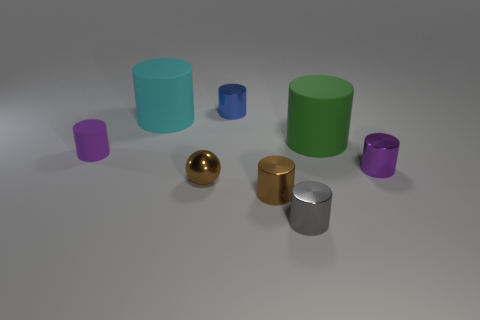Is there any other thing that is the same shape as the purple rubber thing?
Make the answer very short. Yes. Does the purple matte object have the same shape as the large green matte thing?
Keep it short and to the point. Yes. Is the number of metallic balls right of the large green rubber cylinder the same as the number of cyan rubber cylinders that are on the right side of the tiny brown shiny cylinder?
Your answer should be very brief. Yes. What number of other things are the same material as the blue cylinder?
Provide a succinct answer. 4. What number of tiny objects are either brown rubber blocks or purple shiny things?
Your response must be concise. 1. Are there an equal number of large green matte cylinders in front of the tiny brown metal cylinder and brown shiny things?
Give a very brief answer. No. There is a purple cylinder that is on the left side of the tiny purple metal object; is there a tiny brown metal cylinder that is left of it?
Provide a short and direct response. No. How many other things are the same color as the small sphere?
Offer a terse response. 1. The small rubber cylinder is what color?
Provide a short and direct response. Purple. There is a metal cylinder that is both in front of the tiny blue cylinder and on the left side of the gray shiny cylinder; how big is it?
Your answer should be compact. Small. 